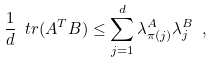Convert formula to latex. <formula><loc_0><loc_0><loc_500><loc_500>\frac { 1 } { d } \ t r ( A ^ { T } B ) \leq \sum _ { j = 1 } ^ { d } \lambda ^ { A } _ { \pi ( j ) } \lambda ^ { B } _ { j } \ ,</formula> 